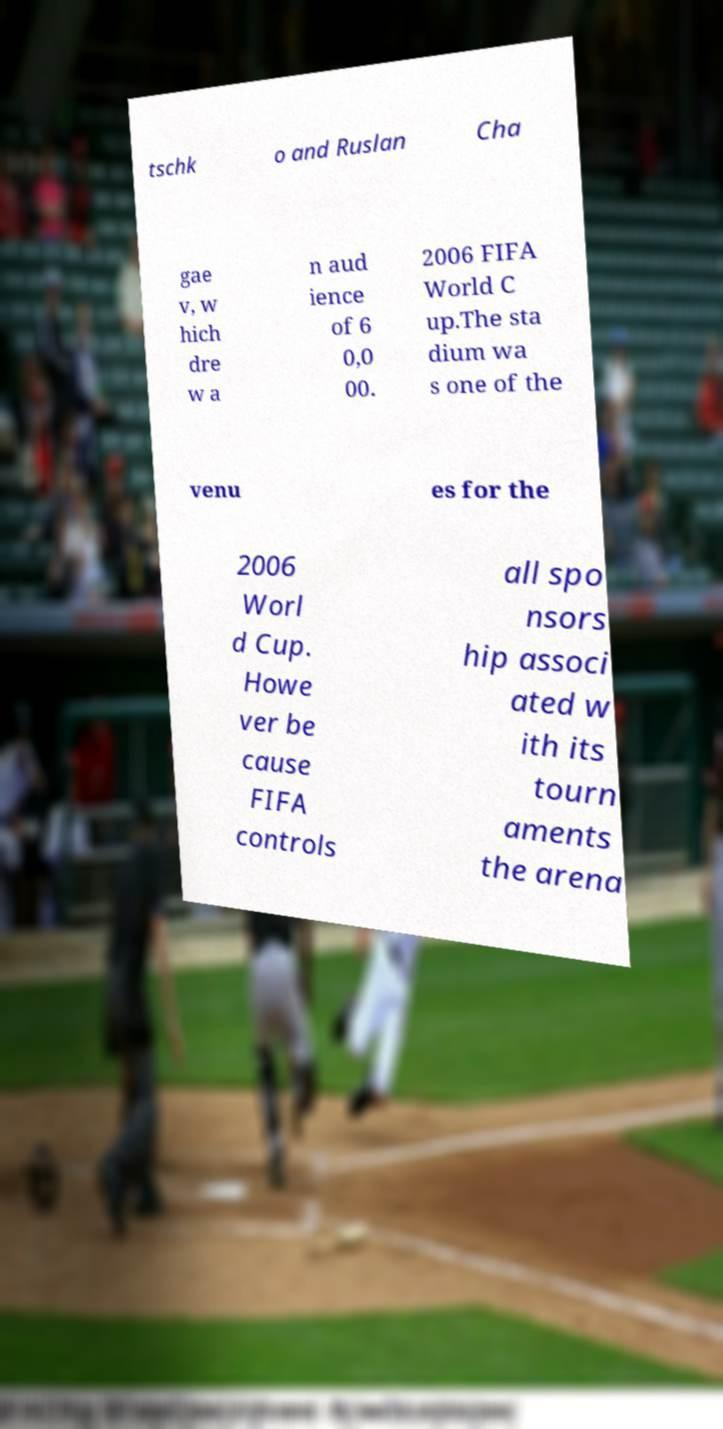Please identify and transcribe the text found in this image. tschk o and Ruslan Cha gae v, w hich dre w a n aud ience of 6 0,0 00. 2006 FIFA World C up.The sta dium wa s one of the venu es for the 2006 Worl d Cup. Howe ver be cause FIFA controls all spo nsors hip associ ated w ith its tourn aments the arena 